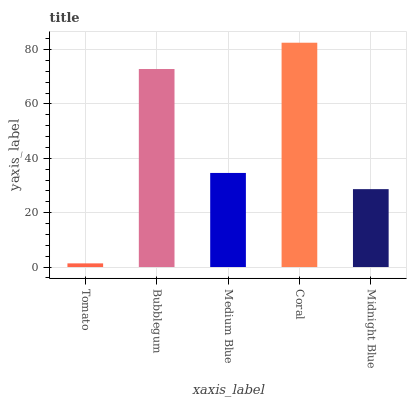Is Tomato the minimum?
Answer yes or no. Yes. Is Coral the maximum?
Answer yes or no. Yes. Is Bubblegum the minimum?
Answer yes or no. No. Is Bubblegum the maximum?
Answer yes or no. No. Is Bubblegum greater than Tomato?
Answer yes or no. Yes. Is Tomato less than Bubblegum?
Answer yes or no. Yes. Is Tomato greater than Bubblegum?
Answer yes or no. No. Is Bubblegum less than Tomato?
Answer yes or no. No. Is Medium Blue the high median?
Answer yes or no. Yes. Is Medium Blue the low median?
Answer yes or no. Yes. Is Midnight Blue the high median?
Answer yes or no. No. Is Midnight Blue the low median?
Answer yes or no. No. 